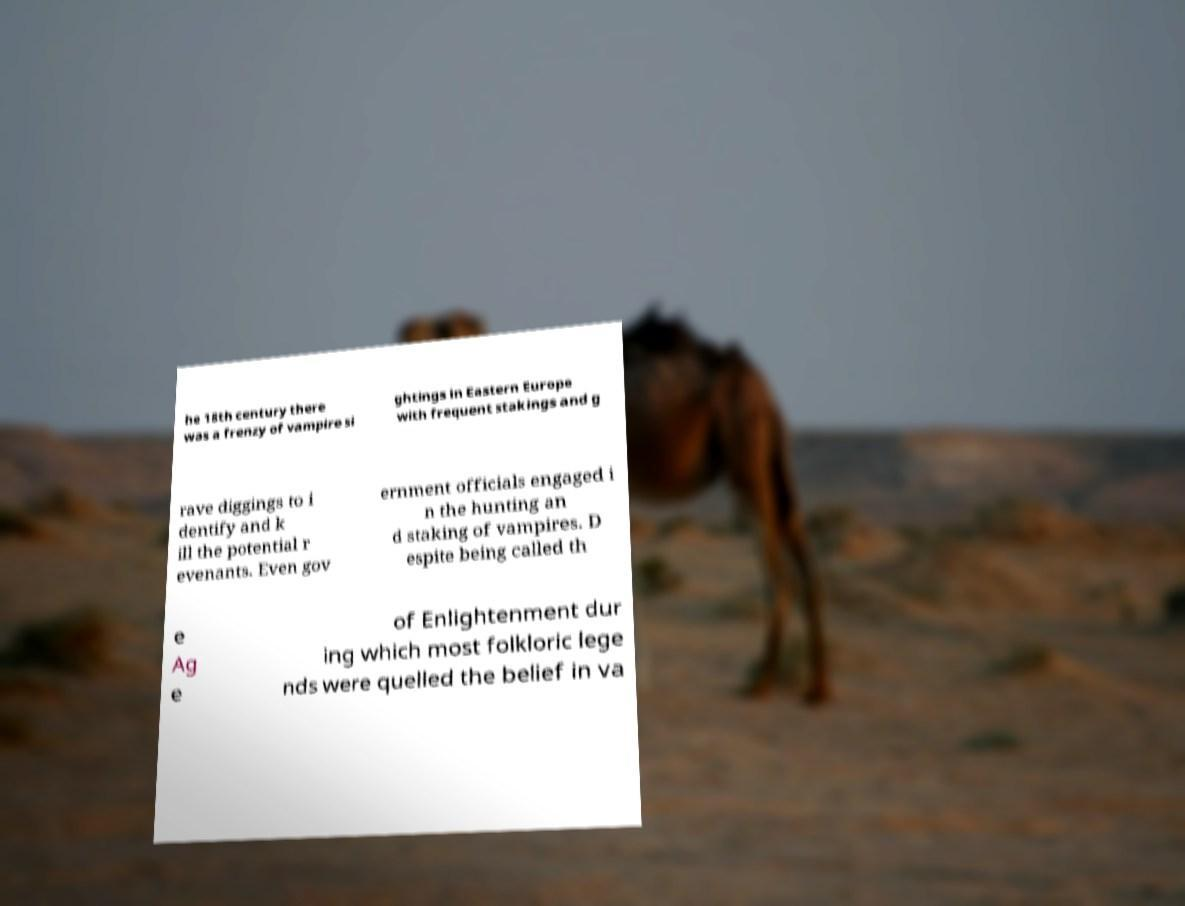What messages or text are displayed in this image? I need them in a readable, typed format. he 18th century there was a frenzy of vampire si ghtings in Eastern Europe with frequent stakings and g rave diggings to i dentify and k ill the potential r evenants. Even gov ernment officials engaged i n the hunting an d staking of vampires. D espite being called th e Ag e of Enlightenment dur ing which most folkloric lege nds were quelled the belief in va 